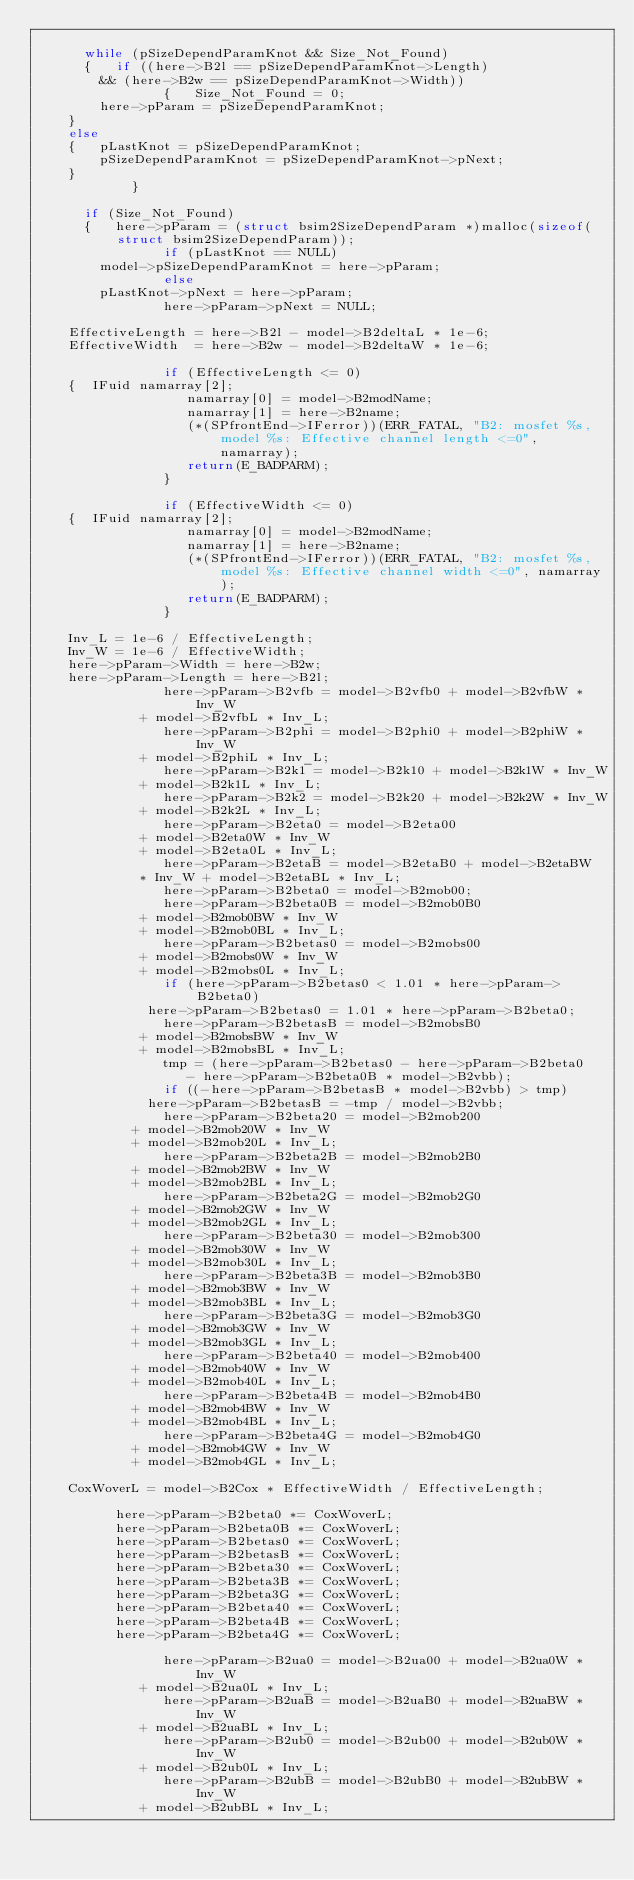<code> <loc_0><loc_0><loc_500><loc_500><_C_>
	    while (pSizeDependParamKnot && Size_Not_Found)
	    {   if ((here->B2l == pSizeDependParamKnot->Length)
		    && (here->B2w == pSizeDependParamKnot->Width))
                {   Size_Not_Found = 0;
		    here->pParam = pSizeDependParamKnot;
		}
		else
		{   pLastKnot = pSizeDependParamKnot;
		    pSizeDependParamKnot = pSizeDependParamKnot->pNext;
		}
            }

	    if (Size_Not_Found)
	    {   here->pParam = (struct bsim2SizeDependParam *)malloc(sizeof(struct bsim2SizeDependParam));
                if (pLastKnot == NULL)
		    model->pSizeDependParamKnot = here->pParam;
                else
		    pLastKnot->pNext = here->pParam;
                here->pParam->pNext = NULL;

		EffectiveLength = here->B2l - model->B2deltaL * 1e-6;
		EffectiveWidth  = here->B2w - model->B2deltaW * 1e-6;

                if (EffectiveLength <= 0)
		{  IFuid namarray[2];
                   namarray[0] = model->B2modName;
                   namarray[1] = here->B2name;
                   (*(SPfrontEnd->IFerror))(ERR_FATAL, "B2: mosfet %s, model %s: Effective channel length <=0", namarray);
                   return(E_BADPARM);
                }

                if (EffectiveWidth <= 0)
		{  IFuid namarray[2];
                   namarray[0] = model->B2modName;
                   namarray[1] = here->B2name;
                   (*(SPfrontEnd->IFerror))(ERR_FATAL, "B2: mosfet %s, model %s: Effective channel width <=0", namarray);
                   return(E_BADPARM);
                }

		Inv_L = 1e-6 / EffectiveLength;
		Inv_W = 1e-6 / EffectiveWidth;
		here->pParam->Width = here->B2w;
		here->pParam->Length = here->B2l;
                here->pParam->B2vfb = model->B2vfb0 + model->B2vfbW * Inv_W
			       + model->B2vfbL * Inv_L;
                here->pParam->B2phi = model->B2phi0 + model->B2phiW * Inv_W
			       + model->B2phiL * Inv_L;
                here->pParam->B2k1 = model->B2k10 + model->B2k1W * Inv_W
			       + model->B2k1L * Inv_L;
                here->pParam->B2k2 = model->B2k20 + model->B2k2W * Inv_W
			       + model->B2k2L * Inv_L;
                here->pParam->B2eta0 = model->B2eta00
			       + model->B2eta0W * Inv_W
			       + model->B2eta0L * Inv_L;
                here->pParam->B2etaB = model->B2etaB0 + model->B2etaBW
			       * Inv_W + model->B2etaBL * Inv_L;
                here->pParam->B2beta0 = model->B2mob00;
                here->pParam->B2beta0B = model->B2mob0B0
			       + model->B2mob0BW * Inv_W
			       + model->B2mob0BL * Inv_L;
                here->pParam->B2betas0 = model->B2mobs00
			       + model->B2mobs0W * Inv_W
			       + model->B2mobs0L * Inv_L;
                if (here->pParam->B2betas0 < 1.01 * here->pParam->B2beta0)
	            here->pParam->B2betas0 = 1.01 * here->pParam->B2beta0;
                here->pParam->B2betasB = model->B2mobsB0
			       + model->B2mobsBW * Inv_W
			       + model->B2mobsBL * Inv_L;
                tmp = (here->pParam->B2betas0 - here->pParam->B2beta0
		               - here->pParam->B2beta0B * model->B2vbb);
                if ((-here->pParam->B2betasB * model->B2vbb) > tmp)
	            here->pParam->B2betasB = -tmp / model->B2vbb;
                here->pParam->B2beta20 = model->B2mob200
			      + model->B2mob20W * Inv_W
			      + model->B2mob20L * Inv_L;
                here->pParam->B2beta2B = model->B2mob2B0
			      + model->B2mob2BW * Inv_W
			      + model->B2mob2BL * Inv_L;
                here->pParam->B2beta2G = model->B2mob2G0
			      + model->B2mob2GW * Inv_W
			      + model->B2mob2GL * Inv_L;
                here->pParam->B2beta30 = model->B2mob300
			      + model->B2mob30W * Inv_W
			      + model->B2mob30L * Inv_L;
                here->pParam->B2beta3B = model->B2mob3B0
			      + model->B2mob3BW * Inv_W
			      + model->B2mob3BL * Inv_L;
                here->pParam->B2beta3G = model->B2mob3G0
			      + model->B2mob3GW * Inv_W
			      + model->B2mob3GL * Inv_L;
                here->pParam->B2beta40 = model->B2mob400
			      + model->B2mob40W * Inv_W
			      + model->B2mob40L * Inv_L;
                here->pParam->B2beta4B = model->B2mob4B0
			      + model->B2mob4BW * Inv_W
			      + model->B2mob4BL * Inv_L;
                here->pParam->B2beta4G = model->B2mob4G0
			      + model->B2mob4GW * Inv_W
			      + model->B2mob4GL * Inv_L;

		CoxWoverL = model->B2Cox * EffectiveWidth / EffectiveLength;

	        here->pParam->B2beta0 *= CoxWoverL;
	        here->pParam->B2beta0B *= CoxWoverL;
	        here->pParam->B2betas0 *= CoxWoverL;
	        here->pParam->B2betasB *= CoxWoverL;
	        here->pParam->B2beta30 *= CoxWoverL;
	        here->pParam->B2beta3B *= CoxWoverL;
	        here->pParam->B2beta3G *= CoxWoverL;
	        here->pParam->B2beta40 *= CoxWoverL;
	        here->pParam->B2beta4B *= CoxWoverL;
	        here->pParam->B2beta4G *= CoxWoverL;

                here->pParam->B2ua0 = model->B2ua00 + model->B2ua0W * Inv_W
			       + model->B2ua0L * Inv_L;
                here->pParam->B2uaB = model->B2uaB0 + model->B2uaBW * Inv_W
			       + model->B2uaBL * Inv_L;
                here->pParam->B2ub0 = model->B2ub00 + model->B2ub0W * Inv_W
			       + model->B2ub0L * Inv_L;
                here->pParam->B2ubB = model->B2ubB0 + model->B2ubBW * Inv_W
			       + model->B2ubBL * Inv_L;</code> 